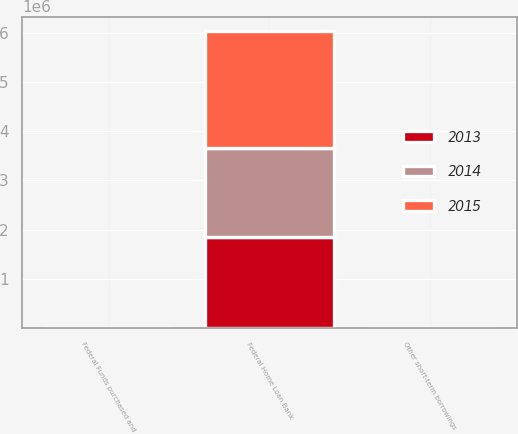<chart> <loc_0><loc_0><loc_500><loc_500><stacked_bar_chart><ecel><fcel>Federal Funds purchased and<fcel>Other short-term borrowings<fcel>Federal Home Loan Bank<nl><fcel>2013<fcel>0.13<fcel>0.27<fcel>1.85e+06<nl><fcel>2015<fcel>0.08<fcel>1.11<fcel>2.375e+06<nl><fcel>2014<fcel>0.06<fcel>2.59<fcel>1.8e+06<nl></chart> 